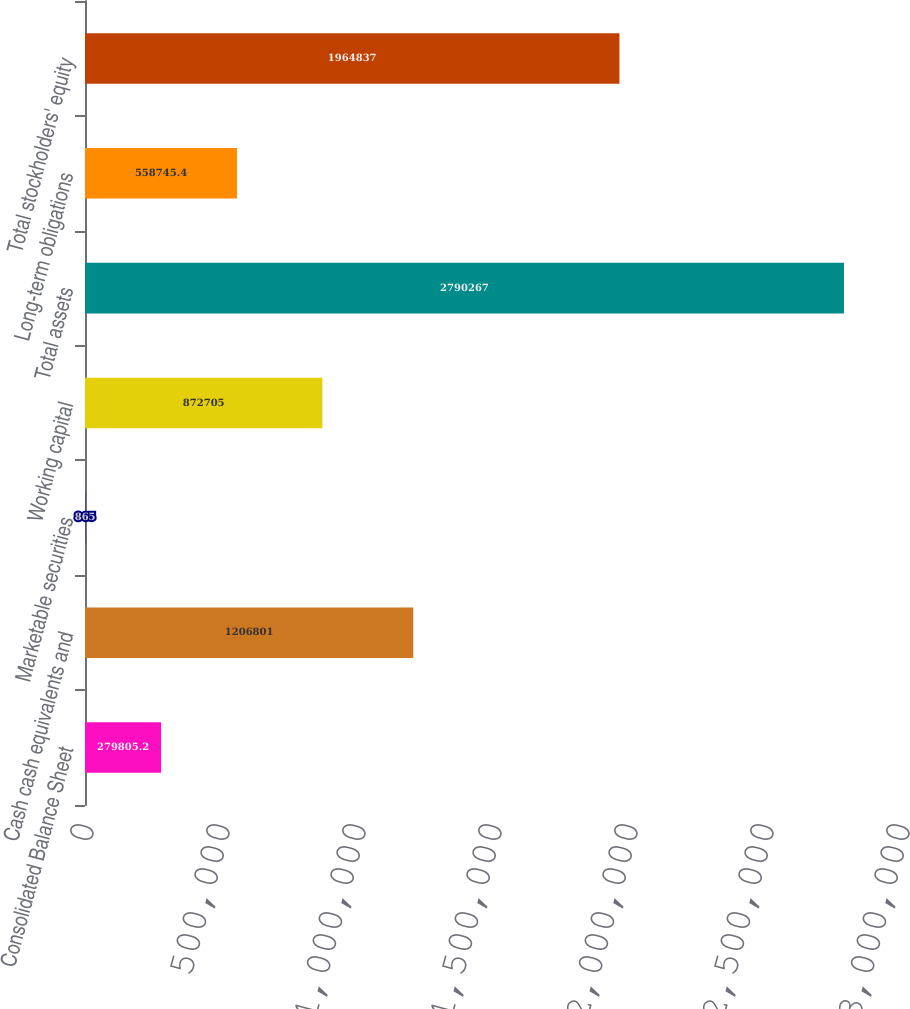<chart> <loc_0><loc_0><loc_500><loc_500><bar_chart><fcel>Consolidated Balance Sheet<fcel>Cash cash equivalents and<fcel>Marketable securities<fcel>Working capital<fcel>Total assets<fcel>Long-term obligations<fcel>Total stockholders' equity<nl><fcel>279805<fcel>1.2068e+06<fcel>865<fcel>872705<fcel>2.79027e+06<fcel>558745<fcel>1.96484e+06<nl></chart> 